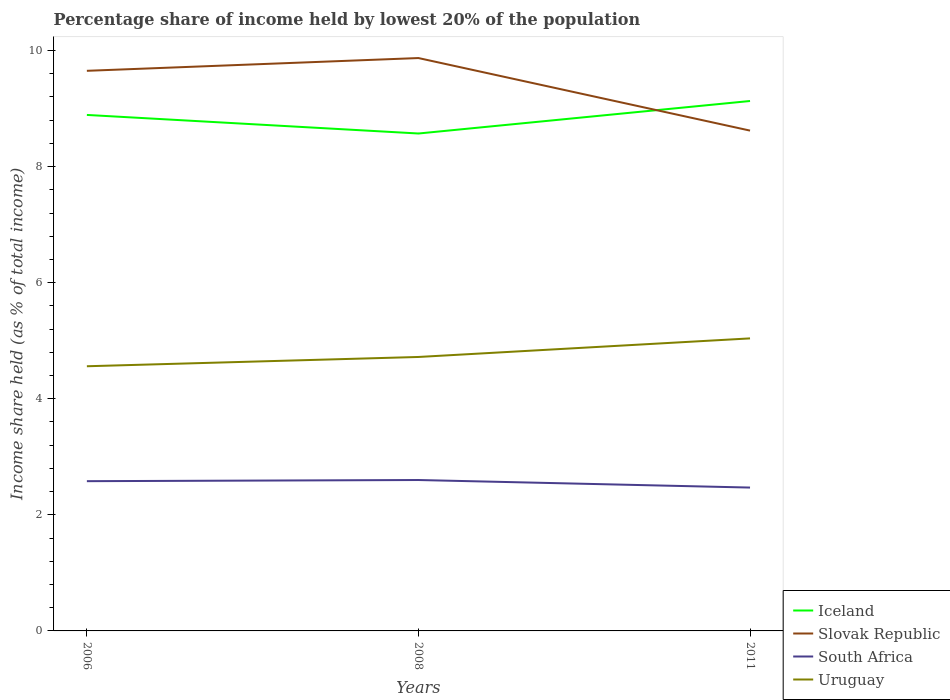Does the line corresponding to Iceland intersect with the line corresponding to South Africa?
Offer a very short reply. No. Is the number of lines equal to the number of legend labels?
Ensure brevity in your answer.  Yes. Across all years, what is the maximum percentage share of income held by lowest 20% of the population in South Africa?
Keep it short and to the point. 2.47. In which year was the percentage share of income held by lowest 20% of the population in Slovak Republic maximum?
Offer a very short reply. 2011. What is the total percentage share of income held by lowest 20% of the population in Iceland in the graph?
Make the answer very short. -0.24. What is the difference between the highest and the second highest percentage share of income held by lowest 20% of the population in Slovak Republic?
Give a very brief answer. 1.25. What is the difference between the highest and the lowest percentage share of income held by lowest 20% of the population in South Africa?
Your response must be concise. 2. How many lines are there?
Give a very brief answer. 4. What is the difference between two consecutive major ticks on the Y-axis?
Keep it short and to the point. 2. Does the graph contain grids?
Offer a terse response. No. What is the title of the graph?
Provide a short and direct response. Percentage share of income held by lowest 20% of the population. Does "Turks and Caicos Islands" appear as one of the legend labels in the graph?
Offer a very short reply. No. What is the label or title of the X-axis?
Your answer should be compact. Years. What is the label or title of the Y-axis?
Your answer should be compact. Income share held (as % of total income). What is the Income share held (as % of total income) in Iceland in 2006?
Offer a very short reply. 8.89. What is the Income share held (as % of total income) in Slovak Republic in 2006?
Provide a succinct answer. 9.65. What is the Income share held (as % of total income) of South Africa in 2006?
Make the answer very short. 2.58. What is the Income share held (as % of total income) of Uruguay in 2006?
Offer a terse response. 4.56. What is the Income share held (as % of total income) of Iceland in 2008?
Offer a terse response. 8.57. What is the Income share held (as % of total income) in Slovak Republic in 2008?
Give a very brief answer. 9.87. What is the Income share held (as % of total income) of South Africa in 2008?
Your answer should be very brief. 2.6. What is the Income share held (as % of total income) of Uruguay in 2008?
Keep it short and to the point. 4.72. What is the Income share held (as % of total income) of Iceland in 2011?
Provide a short and direct response. 9.13. What is the Income share held (as % of total income) in Slovak Republic in 2011?
Offer a very short reply. 8.62. What is the Income share held (as % of total income) of South Africa in 2011?
Make the answer very short. 2.47. What is the Income share held (as % of total income) in Uruguay in 2011?
Provide a short and direct response. 5.04. Across all years, what is the maximum Income share held (as % of total income) of Iceland?
Your answer should be compact. 9.13. Across all years, what is the maximum Income share held (as % of total income) of Slovak Republic?
Provide a succinct answer. 9.87. Across all years, what is the maximum Income share held (as % of total income) in South Africa?
Offer a very short reply. 2.6. Across all years, what is the maximum Income share held (as % of total income) in Uruguay?
Give a very brief answer. 5.04. Across all years, what is the minimum Income share held (as % of total income) in Iceland?
Offer a terse response. 8.57. Across all years, what is the minimum Income share held (as % of total income) of Slovak Republic?
Offer a very short reply. 8.62. Across all years, what is the minimum Income share held (as % of total income) in South Africa?
Offer a terse response. 2.47. Across all years, what is the minimum Income share held (as % of total income) of Uruguay?
Make the answer very short. 4.56. What is the total Income share held (as % of total income) in Iceland in the graph?
Provide a short and direct response. 26.59. What is the total Income share held (as % of total income) in Slovak Republic in the graph?
Offer a terse response. 28.14. What is the total Income share held (as % of total income) of South Africa in the graph?
Make the answer very short. 7.65. What is the total Income share held (as % of total income) in Uruguay in the graph?
Your response must be concise. 14.32. What is the difference between the Income share held (as % of total income) of Iceland in 2006 and that in 2008?
Make the answer very short. 0.32. What is the difference between the Income share held (as % of total income) of Slovak Republic in 2006 and that in 2008?
Keep it short and to the point. -0.22. What is the difference between the Income share held (as % of total income) in South Africa in 2006 and that in 2008?
Offer a very short reply. -0.02. What is the difference between the Income share held (as % of total income) in Uruguay in 2006 and that in 2008?
Provide a short and direct response. -0.16. What is the difference between the Income share held (as % of total income) in Iceland in 2006 and that in 2011?
Make the answer very short. -0.24. What is the difference between the Income share held (as % of total income) in South Africa in 2006 and that in 2011?
Your answer should be compact. 0.11. What is the difference between the Income share held (as % of total income) of Uruguay in 2006 and that in 2011?
Ensure brevity in your answer.  -0.48. What is the difference between the Income share held (as % of total income) in Iceland in 2008 and that in 2011?
Provide a succinct answer. -0.56. What is the difference between the Income share held (as % of total income) in South Africa in 2008 and that in 2011?
Provide a succinct answer. 0.13. What is the difference between the Income share held (as % of total income) in Uruguay in 2008 and that in 2011?
Provide a succinct answer. -0.32. What is the difference between the Income share held (as % of total income) in Iceland in 2006 and the Income share held (as % of total income) in Slovak Republic in 2008?
Your answer should be very brief. -0.98. What is the difference between the Income share held (as % of total income) in Iceland in 2006 and the Income share held (as % of total income) in South Africa in 2008?
Give a very brief answer. 6.29. What is the difference between the Income share held (as % of total income) in Iceland in 2006 and the Income share held (as % of total income) in Uruguay in 2008?
Offer a terse response. 4.17. What is the difference between the Income share held (as % of total income) in Slovak Republic in 2006 and the Income share held (as % of total income) in South Africa in 2008?
Provide a succinct answer. 7.05. What is the difference between the Income share held (as % of total income) of Slovak Republic in 2006 and the Income share held (as % of total income) of Uruguay in 2008?
Provide a short and direct response. 4.93. What is the difference between the Income share held (as % of total income) of South Africa in 2006 and the Income share held (as % of total income) of Uruguay in 2008?
Offer a terse response. -2.14. What is the difference between the Income share held (as % of total income) of Iceland in 2006 and the Income share held (as % of total income) of Slovak Republic in 2011?
Ensure brevity in your answer.  0.27. What is the difference between the Income share held (as % of total income) in Iceland in 2006 and the Income share held (as % of total income) in South Africa in 2011?
Your answer should be very brief. 6.42. What is the difference between the Income share held (as % of total income) of Iceland in 2006 and the Income share held (as % of total income) of Uruguay in 2011?
Ensure brevity in your answer.  3.85. What is the difference between the Income share held (as % of total income) in Slovak Republic in 2006 and the Income share held (as % of total income) in South Africa in 2011?
Offer a very short reply. 7.18. What is the difference between the Income share held (as % of total income) of Slovak Republic in 2006 and the Income share held (as % of total income) of Uruguay in 2011?
Offer a very short reply. 4.61. What is the difference between the Income share held (as % of total income) in South Africa in 2006 and the Income share held (as % of total income) in Uruguay in 2011?
Provide a short and direct response. -2.46. What is the difference between the Income share held (as % of total income) of Iceland in 2008 and the Income share held (as % of total income) of Slovak Republic in 2011?
Make the answer very short. -0.05. What is the difference between the Income share held (as % of total income) of Iceland in 2008 and the Income share held (as % of total income) of Uruguay in 2011?
Make the answer very short. 3.53. What is the difference between the Income share held (as % of total income) of Slovak Republic in 2008 and the Income share held (as % of total income) of South Africa in 2011?
Keep it short and to the point. 7.4. What is the difference between the Income share held (as % of total income) of Slovak Republic in 2008 and the Income share held (as % of total income) of Uruguay in 2011?
Ensure brevity in your answer.  4.83. What is the difference between the Income share held (as % of total income) of South Africa in 2008 and the Income share held (as % of total income) of Uruguay in 2011?
Ensure brevity in your answer.  -2.44. What is the average Income share held (as % of total income) in Iceland per year?
Provide a succinct answer. 8.86. What is the average Income share held (as % of total income) of Slovak Republic per year?
Keep it short and to the point. 9.38. What is the average Income share held (as % of total income) in South Africa per year?
Your response must be concise. 2.55. What is the average Income share held (as % of total income) in Uruguay per year?
Ensure brevity in your answer.  4.77. In the year 2006, what is the difference between the Income share held (as % of total income) of Iceland and Income share held (as % of total income) of Slovak Republic?
Provide a succinct answer. -0.76. In the year 2006, what is the difference between the Income share held (as % of total income) in Iceland and Income share held (as % of total income) in South Africa?
Your response must be concise. 6.31. In the year 2006, what is the difference between the Income share held (as % of total income) in Iceland and Income share held (as % of total income) in Uruguay?
Your answer should be compact. 4.33. In the year 2006, what is the difference between the Income share held (as % of total income) in Slovak Republic and Income share held (as % of total income) in South Africa?
Give a very brief answer. 7.07. In the year 2006, what is the difference between the Income share held (as % of total income) of Slovak Republic and Income share held (as % of total income) of Uruguay?
Make the answer very short. 5.09. In the year 2006, what is the difference between the Income share held (as % of total income) of South Africa and Income share held (as % of total income) of Uruguay?
Your answer should be very brief. -1.98. In the year 2008, what is the difference between the Income share held (as % of total income) in Iceland and Income share held (as % of total income) in South Africa?
Keep it short and to the point. 5.97. In the year 2008, what is the difference between the Income share held (as % of total income) of Iceland and Income share held (as % of total income) of Uruguay?
Provide a succinct answer. 3.85. In the year 2008, what is the difference between the Income share held (as % of total income) of Slovak Republic and Income share held (as % of total income) of South Africa?
Your response must be concise. 7.27. In the year 2008, what is the difference between the Income share held (as % of total income) of Slovak Republic and Income share held (as % of total income) of Uruguay?
Your answer should be compact. 5.15. In the year 2008, what is the difference between the Income share held (as % of total income) in South Africa and Income share held (as % of total income) in Uruguay?
Your answer should be very brief. -2.12. In the year 2011, what is the difference between the Income share held (as % of total income) in Iceland and Income share held (as % of total income) in Slovak Republic?
Your answer should be very brief. 0.51. In the year 2011, what is the difference between the Income share held (as % of total income) in Iceland and Income share held (as % of total income) in South Africa?
Ensure brevity in your answer.  6.66. In the year 2011, what is the difference between the Income share held (as % of total income) in Iceland and Income share held (as % of total income) in Uruguay?
Provide a short and direct response. 4.09. In the year 2011, what is the difference between the Income share held (as % of total income) in Slovak Republic and Income share held (as % of total income) in South Africa?
Ensure brevity in your answer.  6.15. In the year 2011, what is the difference between the Income share held (as % of total income) in Slovak Republic and Income share held (as % of total income) in Uruguay?
Give a very brief answer. 3.58. In the year 2011, what is the difference between the Income share held (as % of total income) in South Africa and Income share held (as % of total income) in Uruguay?
Offer a very short reply. -2.57. What is the ratio of the Income share held (as % of total income) of Iceland in 2006 to that in 2008?
Ensure brevity in your answer.  1.04. What is the ratio of the Income share held (as % of total income) in Slovak Republic in 2006 to that in 2008?
Give a very brief answer. 0.98. What is the ratio of the Income share held (as % of total income) of Uruguay in 2006 to that in 2008?
Your answer should be compact. 0.97. What is the ratio of the Income share held (as % of total income) in Iceland in 2006 to that in 2011?
Keep it short and to the point. 0.97. What is the ratio of the Income share held (as % of total income) in Slovak Republic in 2006 to that in 2011?
Provide a succinct answer. 1.12. What is the ratio of the Income share held (as % of total income) of South Africa in 2006 to that in 2011?
Ensure brevity in your answer.  1.04. What is the ratio of the Income share held (as % of total income) of Uruguay in 2006 to that in 2011?
Make the answer very short. 0.9. What is the ratio of the Income share held (as % of total income) in Iceland in 2008 to that in 2011?
Provide a succinct answer. 0.94. What is the ratio of the Income share held (as % of total income) in Slovak Republic in 2008 to that in 2011?
Provide a succinct answer. 1.15. What is the ratio of the Income share held (as % of total income) in South Africa in 2008 to that in 2011?
Your response must be concise. 1.05. What is the ratio of the Income share held (as % of total income) in Uruguay in 2008 to that in 2011?
Offer a terse response. 0.94. What is the difference between the highest and the second highest Income share held (as % of total income) of Iceland?
Provide a succinct answer. 0.24. What is the difference between the highest and the second highest Income share held (as % of total income) in Slovak Republic?
Your answer should be compact. 0.22. What is the difference between the highest and the second highest Income share held (as % of total income) of South Africa?
Make the answer very short. 0.02. What is the difference between the highest and the second highest Income share held (as % of total income) in Uruguay?
Provide a short and direct response. 0.32. What is the difference between the highest and the lowest Income share held (as % of total income) of Iceland?
Give a very brief answer. 0.56. What is the difference between the highest and the lowest Income share held (as % of total income) in Slovak Republic?
Ensure brevity in your answer.  1.25. What is the difference between the highest and the lowest Income share held (as % of total income) in South Africa?
Your answer should be compact. 0.13. What is the difference between the highest and the lowest Income share held (as % of total income) of Uruguay?
Your answer should be compact. 0.48. 